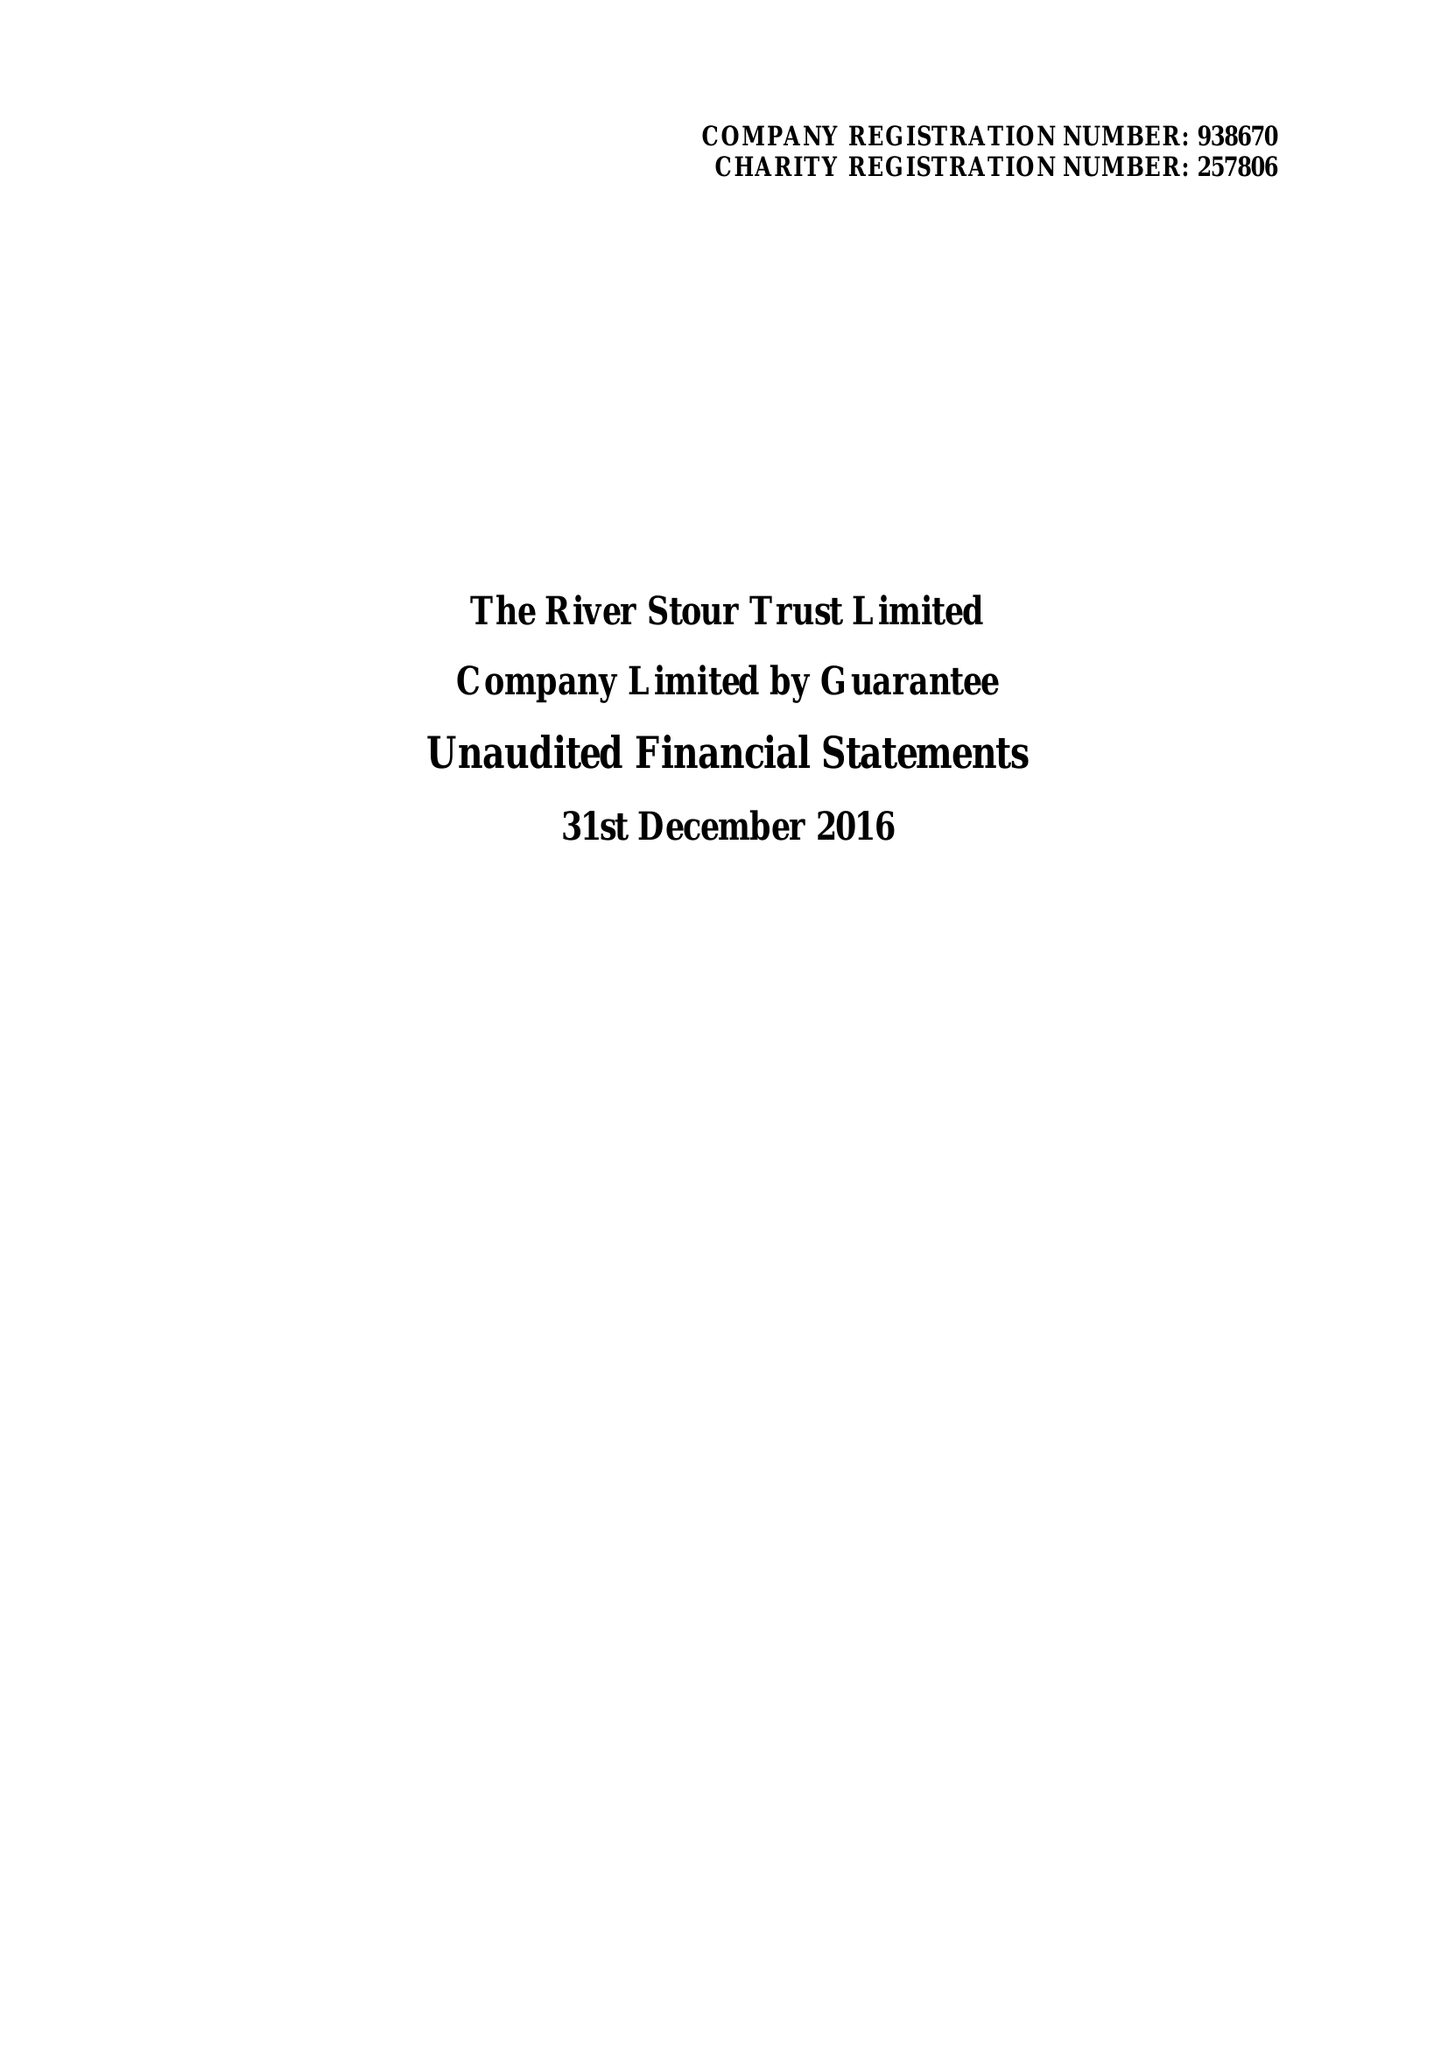What is the value for the address__street_line?
Answer the question using a single word or phrase. None 